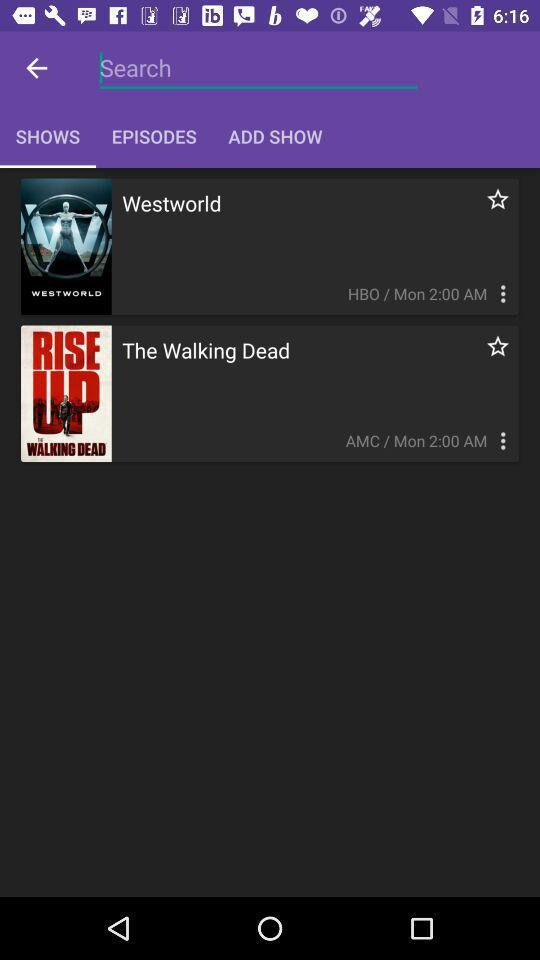What is the selected tab? The selected tab is "SHOWS". 